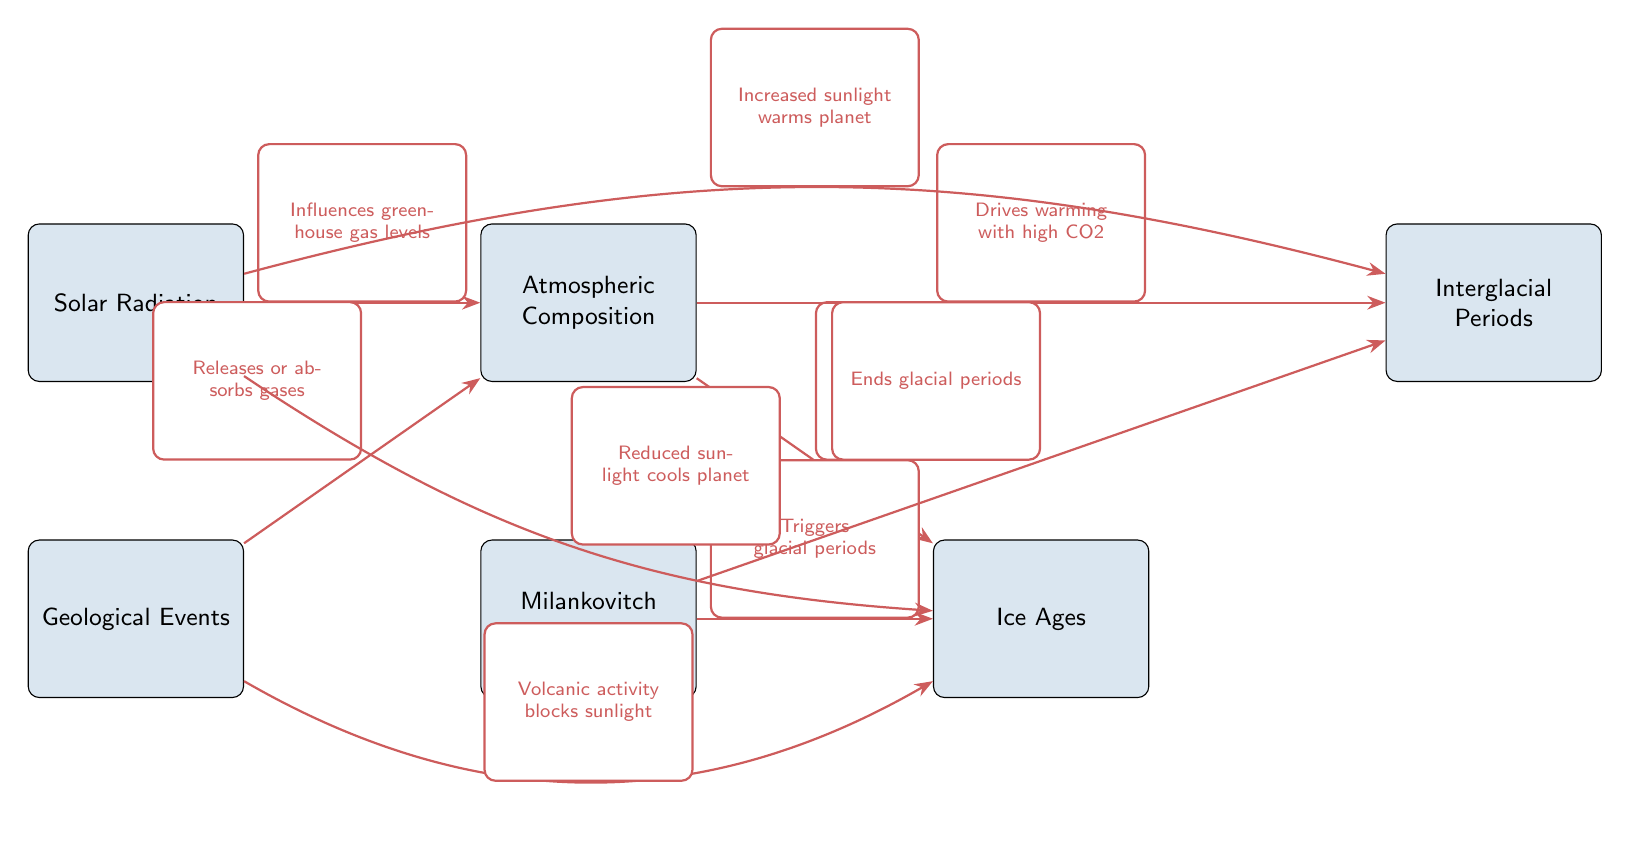What influences greenhouse gas levels? The diagram shows an edge from the Solar Radiation node to the Atmospheric Composition node labeled "Influences greenhouse gas levels," indicating that solar radiation has a direct effect on the levels of greenhouse gases in the atmosphere.
Answer: Solar Radiation What drives cooling with low CO2? The edge from the Atmospheric Composition node to the Ice Ages node states, "Drives cooling with low CO2." This shows that a lower concentration of CO2 in the atmosphere contributes to cooling periods on the planet, leading to ice ages.
Answer: Atmospheric Composition How many nodes are in the diagram? By counting the nodes present in the diagram, we can identify six distinct entities: Solar Radiation, Atmospheric Composition, Geological Events, Milankovitch Cycles, Ice Ages, and Interglacial Periods. Therefore, the total is six nodes.
Answer: 6 Which period does Milankovitch Cycles trigger? The diagram indicates that Milankovitch Cycles have an edge to the Ice Ages node labeled "Triggers glacial periods." This means that these cycles are responsible for initiating ice ages on the planet.
Answer: Ice Ages What effect does increased sunlight have on the planet? The edge leading from the Solar Radiation node to the Interglacial Periods node is labeled "Increased sunlight warms planet." This implies that more solar radiation contributes to warmer temperatures, associated with interglacial periods.
Answer: Warms planet How does geological activity affect atmospheric composition? There is an edge from the Geological Events node to the Atmospheric Composition node saying, "Releases or absorbs gases." This indicates that geological activities directly alter the composition of the atmosphere by either adding or removing gases.
Answer: Releases or absorbs gases What ends glacial periods? The diagram shows Milankovitch Cycles leading to the Interglacial Periods node with an edge labeled "Ends glacial periods." This means that changes in these cycles are responsible for the conclusion of ice ages.
Answer: Milankovitch Cycles Which node indicates a cooling effect on the planet? The Ice Ages node indicates a cooling effect as it is directly connected to both the Atmospheric Composition node (indicating cooling with low CO2) and is also influenced by reduced sunlight, as shown in the edges.
Answer: Ice Ages What phenomenon drives warming with high CO2? According to the diagram, the edge from the Atmospheric Composition to the Interglacial Periods node states "Drives warming with high CO2," implying that increased levels of CO2 lead to warmer conditions, typically associated with interglacial times.
Answer: Atmospheric Composition 